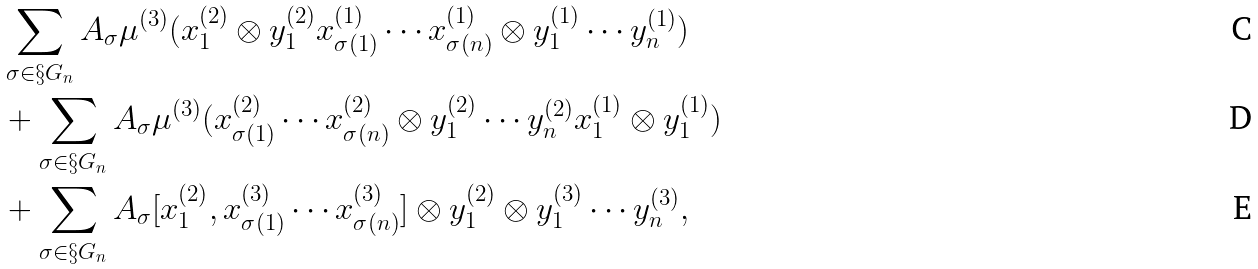Convert formula to latex. <formula><loc_0><loc_0><loc_500><loc_500>& \sum _ { \sigma \in \S G _ { n } } A _ { \sigma } \mu ^ { ( 3 ) } ( x ^ { ( 2 ) } _ { 1 } \otimes y ^ { ( 2 ) } _ { 1 } x ^ { ( 1 ) } _ { \sigma ( 1 ) } \cdots x ^ { ( 1 ) } _ { \sigma ( n ) } \otimes y ^ { ( 1 ) } _ { 1 } \cdots y ^ { ( 1 ) } _ { n } ) \\ & + \sum _ { \sigma \in \S G _ { n } } A _ { \sigma } \mu ^ { ( 3 ) } ( x ^ { ( 2 ) } _ { \sigma ( 1 ) } \cdots x ^ { ( 2 ) } _ { \sigma ( n ) } \otimes y ^ { ( 2 ) } _ { 1 } \cdots y ^ { ( 2 ) } _ { n } x ^ { ( 1 ) } _ { 1 } \otimes y ^ { ( 1 ) } _ { 1 } ) \\ & + \sum _ { \sigma \in \S G _ { n } } A _ { \sigma } [ x ^ { ( 2 ) } _ { 1 } , x ^ { ( 3 ) } _ { \sigma ( 1 ) } \cdots x ^ { ( 3 ) } _ { \sigma ( n ) } ] \otimes y ^ { ( 2 ) } _ { 1 } \otimes y ^ { ( 3 ) } _ { 1 } \cdots y ^ { ( 3 ) } _ { n } ,</formula> 